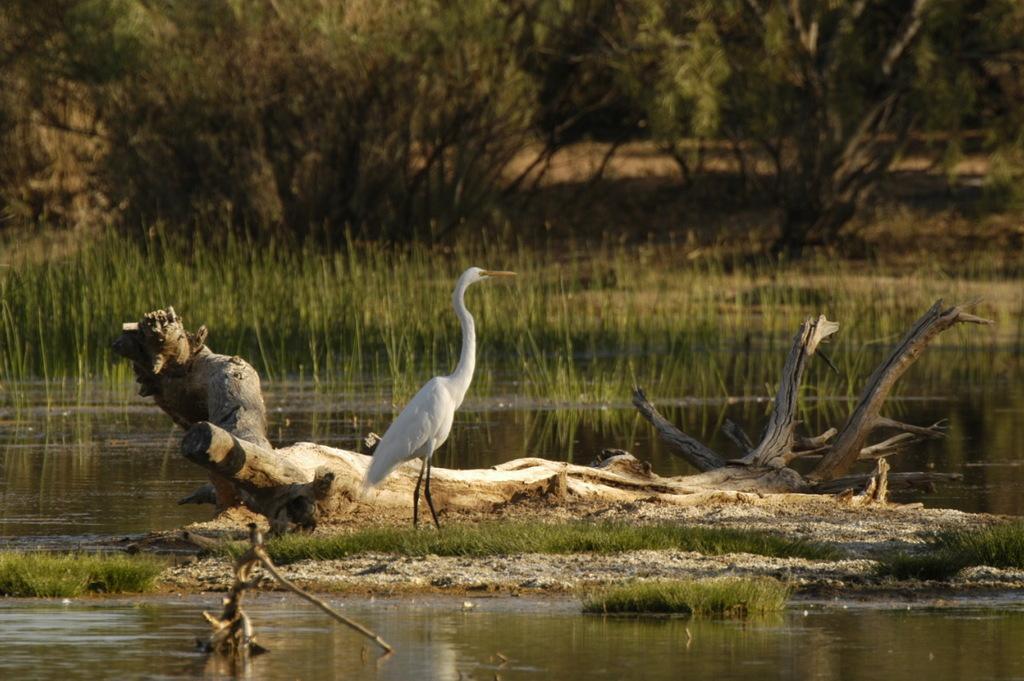Can you describe this image briefly? This is water and there is a bird. Here we can see grass. In the background there are trees. 